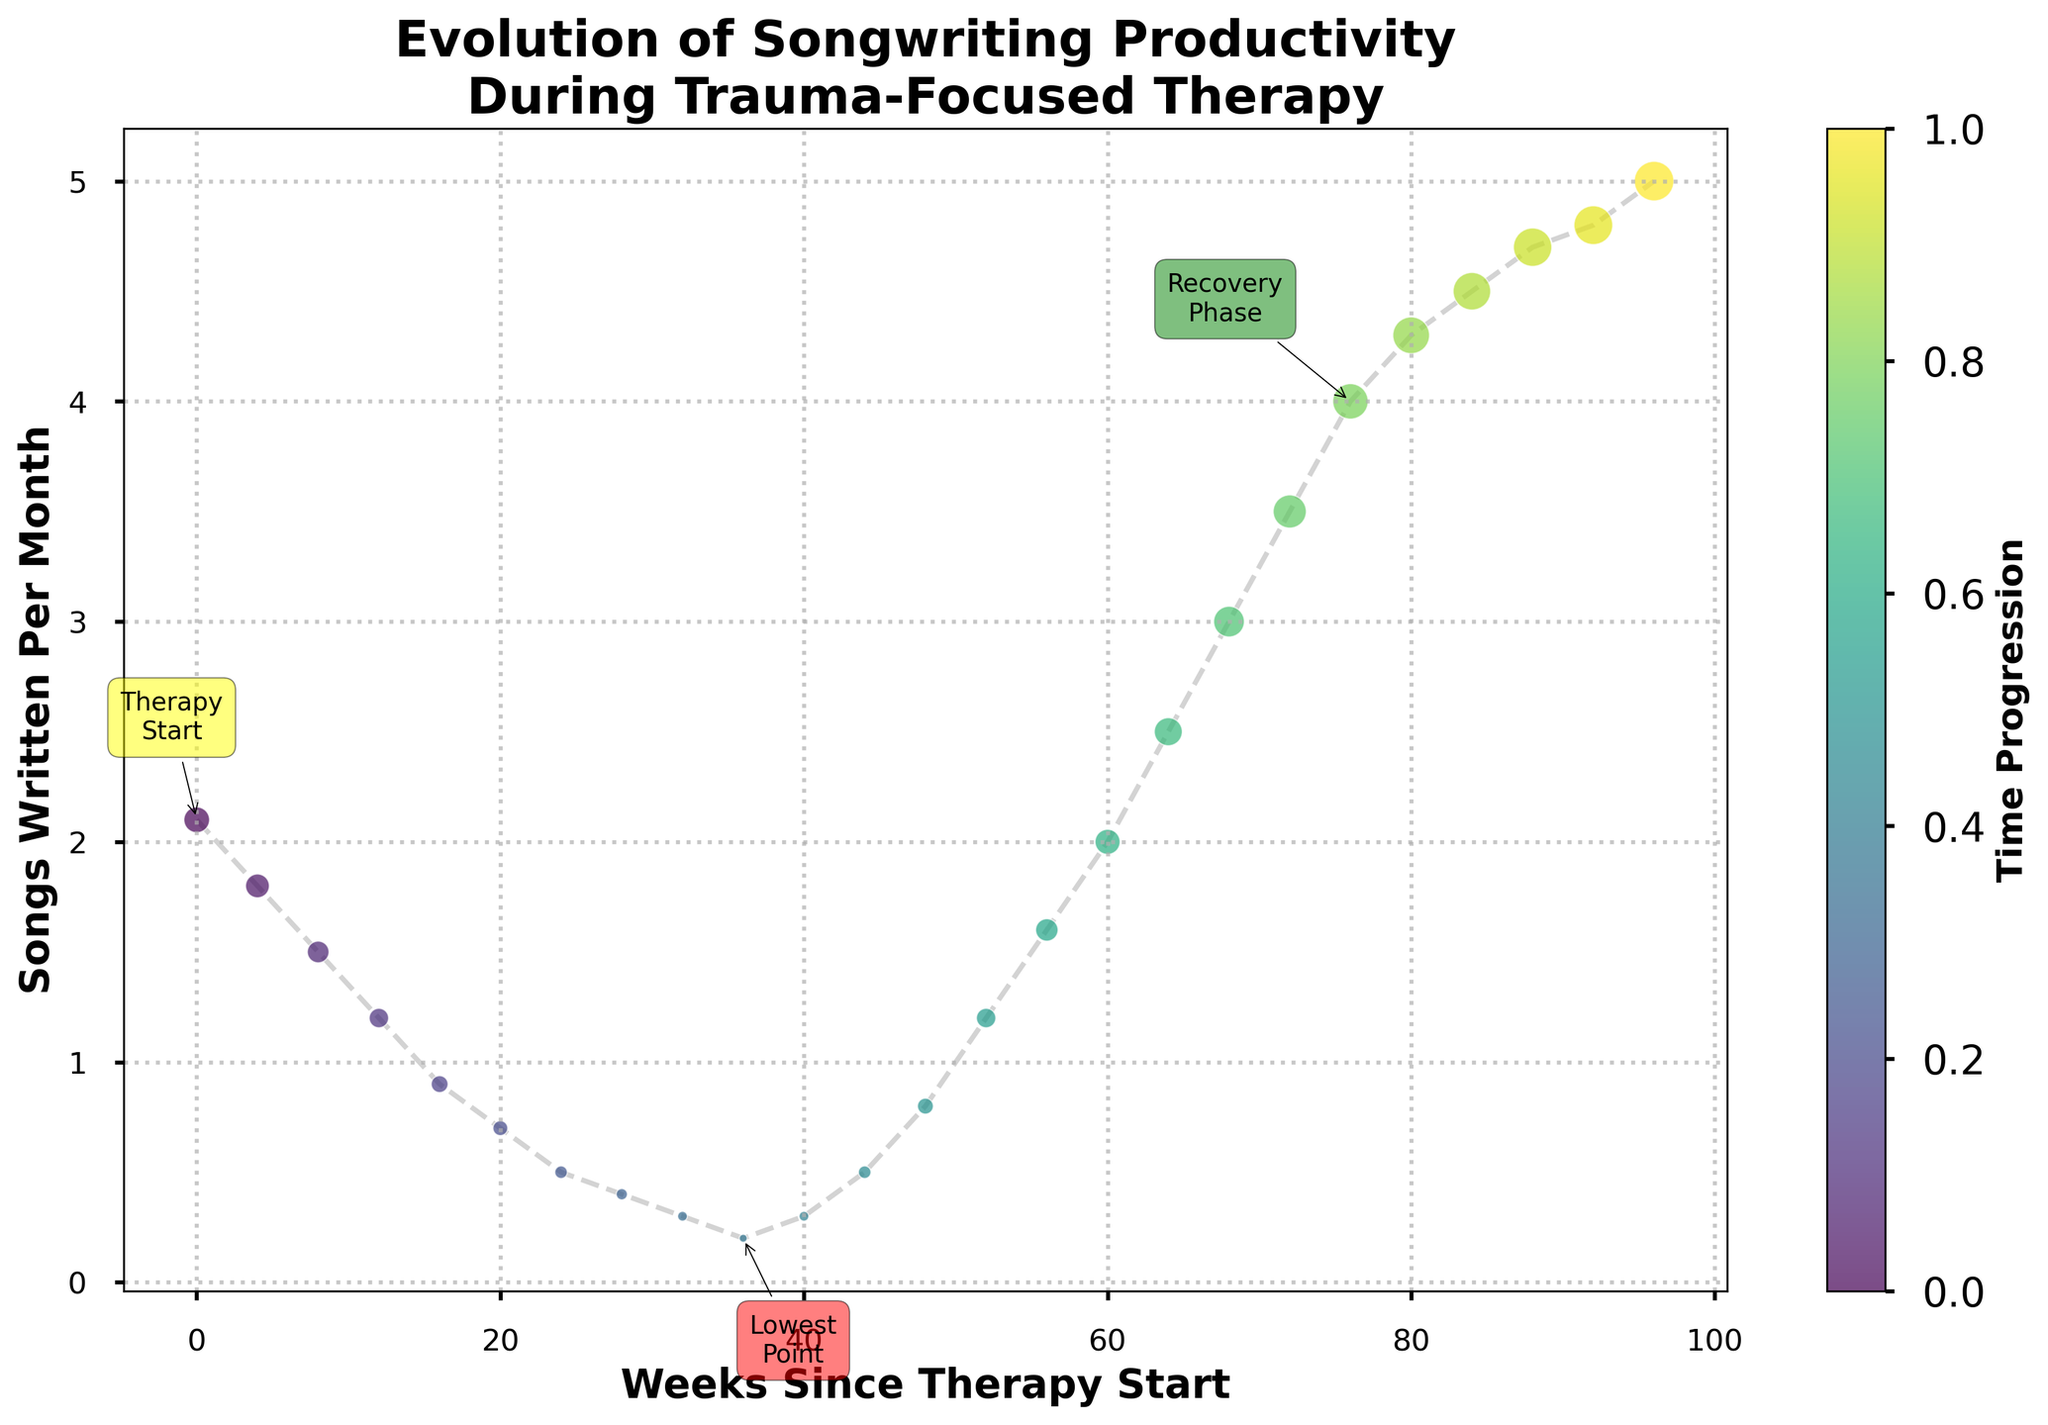How many songs per month were written at the start of therapy? The figure shows an annotation labeled "Therapy Start" at the 0-week mark on the x-axis. The corresponding y-value at this point is 2.1, indicating 2.1 songs were written per month at the start of therapy.
Answer: 2.1 When was the songwriting productivity at its lowest, and what was the productivity rate? The figure shows an annotation labeled "Lowest Point" at the 36-week mark on the x-axis. The corresponding y-value at this point is 0.2, indicating 0.2 songs written per month.
Answer: 36 weeks, 0.2 songs/month Compare the productivity rate at the 24-week mark and the 64-week mark. How much did it increase? At the 24-week mark, the y-value is 0.5 songs/month. At the 64-week mark, the y-value is 2.5 songs/month. The increase is calculated by finding the difference: 2.5 - 0.5 = 2.0 songs/month.
Answer: 2.0 songs/month Describe the change in songwriting productivity from the start of therapy to the lowest point. At the start of therapy (0 weeks), the productivity rate is 2.1 songs/month. At the lowest point (36 weeks), the rate is 0.2 songs/month. The change is calculated by finding the difference: 2.1 - 0.2 = 1.9 songs/month.
Answer: Decreased by 1.9 songs/month What is the average monthly songwriting productivity from weeks 40 to 52? From the data: at week 40, the productivity is 0.3; at week 44, it is 0.5; at week 48, it is 0.8; and at week 52, it is 1.2. The average is calculated by summing these values and dividing by the number of data points: (0.3 + 0.5 + 0.8 + 1.2) / 4 = 2.8 / 4 = 0.7.
Answer: 0.7 songs/month How does the rate of increase in productivity compare between the periods 36-52 weeks and 72-88 weeks? From week 36 to 52, the productivity increases from 0.2 to 1.2. The increase rate = (1.2 - 0.2) / (52 - 36) = 1.0 / 16 = 0.0625 songs/week. From week 72 to 88, it increases from 3.5 to 4.7. The increase rate = (4.7 - 3.5) / (88 - 72) = 1.2 / 16 = 0.075 songs/week.
Answer: Second period has a higher rate of increase (0.075 songs/week vs 0.0625 songs/week) What visual cues indicate the recovery phase in songwriting productivity? The figure shows an annotation labeled "Recovery Phase" at the 76-week mark, with a green annotation box pointing to an upward trend in the productivity line, signaling the recovery.
Answer: Upward trend with green annotation At what point does the songwriting productivity reach 4 songs per month, and what does this signify? The figure shows the curve reaching the 4 songs/month mark at the 76-week point. This is labeled and signified as the "Recovery Phase" in the plot.
Answer: 76 weeks, signifies recovery phase Calculate the total increase in songwriting productivity from the lowest point to the final data point. At the lowest point (36 weeks), the productivity is 0.2 songs/month. At the final data point (96 weeks), it is 5.0 songs/month. The total increase is calculated by finding the difference: 5.0 - 0.2 = 4.8 songs/month.
Answer: 4.8 songs/month הר 